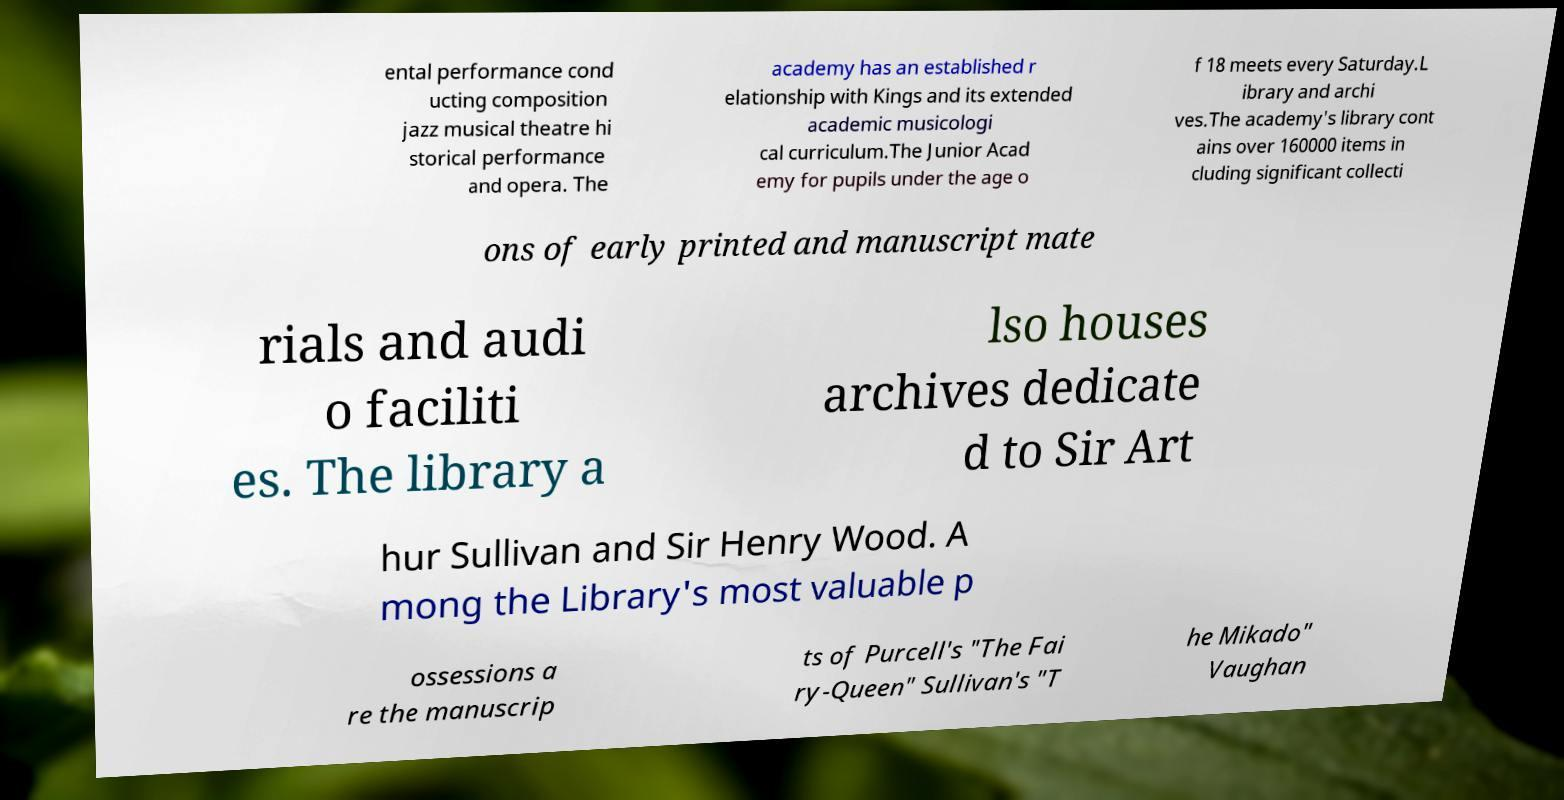Can you read and provide the text displayed in the image?This photo seems to have some interesting text. Can you extract and type it out for me? ental performance cond ucting composition jazz musical theatre hi storical performance and opera. The academy has an established r elationship with Kings and its extended academic musicologi cal curriculum.The Junior Acad emy for pupils under the age o f 18 meets every Saturday.L ibrary and archi ves.The academy's library cont ains over 160000 items in cluding significant collecti ons of early printed and manuscript mate rials and audi o faciliti es. The library a lso houses archives dedicate d to Sir Art hur Sullivan and Sir Henry Wood. A mong the Library's most valuable p ossessions a re the manuscrip ts of Purcell's "The Fai ry-Queen" Sullivan's "T he Mikado" Vaughan 